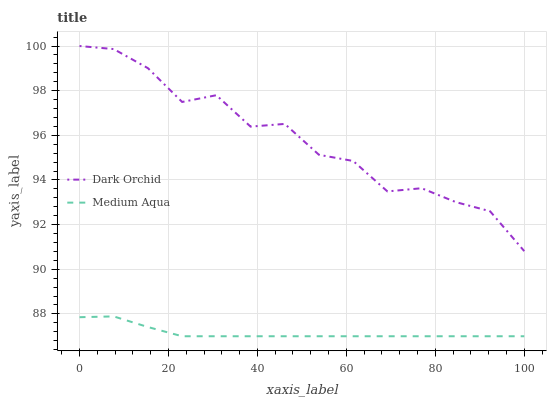Does Dark Orchid have the minimum area under the curve?
Answer yes or no. No. Is Dark Orchid the smoothest?
Answer yes or no. No. Does Dark Orchid have the lowest value?
Answer yes or no. No. Is Medium Aqua less than Dark Orchid?
Answer yes or no. Yes. Is Dark Orchid greater than Medium Aqua?
Answer yes or no. Yes. Does Medium Aqua intersect Dark Orchid?
Answer yes or no. No. 